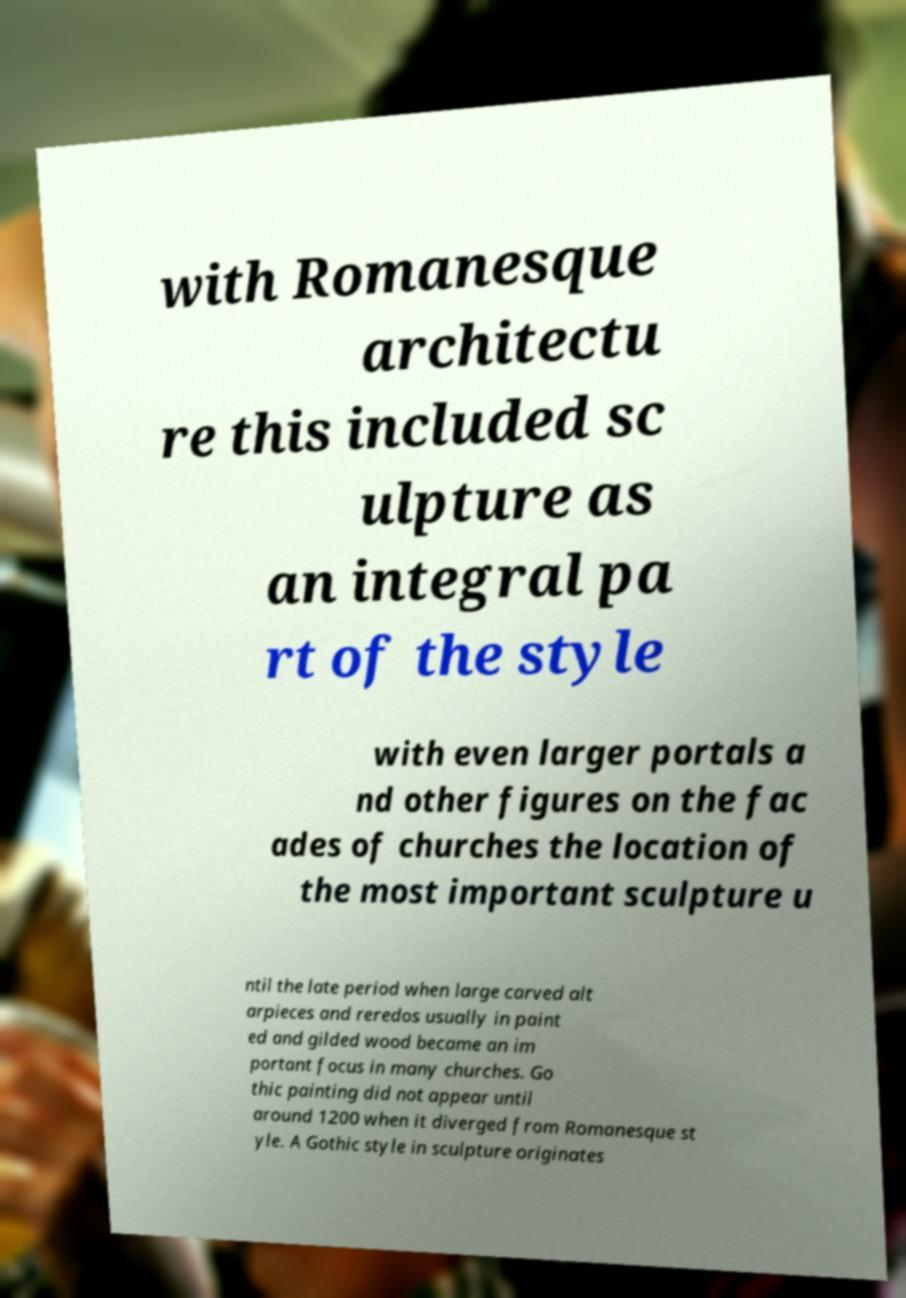I need the written content from this picture converted into text. Can you do that? with Romanesque architectu re this included sc ulpture as an integral pa rt of the style with even larger portals a nd other figures on the fac ades of churches the location of the most important sculpture u ntil the late period when large carved alt arpieces and reredos usually in paint ed and gilded wood became an im portant focus in many churches. Go thic painting did not appear until around 1200 when it diverged from Romanesque st yle. A Gothic style in sculpture originates 